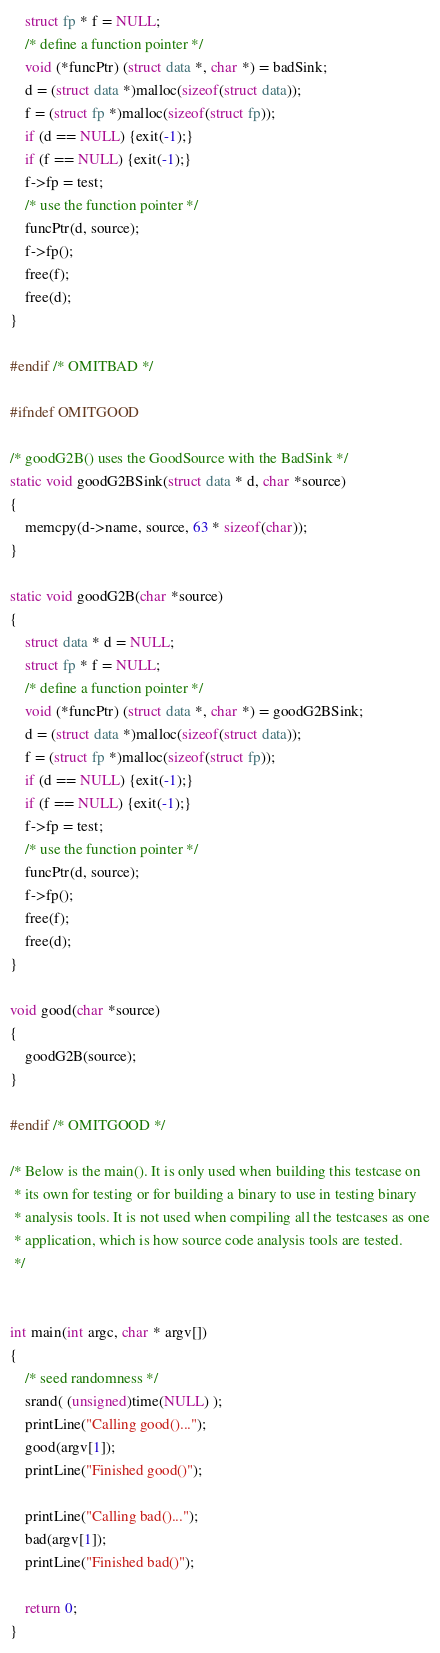<code> <loc_0><loc_0><loc_500><loc_500><_C_>    struct fp * f = NULL;
    /* define a function pointer */
    void (*funcPtr) (struct data *, char *) = badSink;
	d = (struct data *)malloc(sizeof(struct data));
	f = (struct fp *)malloc(sizeof(struct fp));
    if (d == NULL) {exit(-1);}
    if (f == NULL) {exit(-1);}
    f->fp = test;
    /* use the function pointer */
    funcPtr(d, source);
    f->fp();
    free(f);
    free(d);
}

#endif /* OMITBAD */

#ifndef OMITGOOD

/* goodG2B() uses the GoodSource with the BadSink */
static void goodG2BSink(struct data * d, char *source)
{
    memcpy(d->name, source, 63 * sizeof(char));
}

static void goodG2B(char *source)
{
    struct data * d = NULL;
    struct fp * f = NULL;
    /* define a function pointer */
    void (*funcPtr) (struct data *, char *) = goodG2BSink;
	d = (struct data *)malloc(sizeof(struct data));
	f = (struct fp *)malloc(sizeof(struct fp));
    if (d == NULL) {exit(-1);}
    if (f == NULL) {exit(-1);}
    f->fp = test;
    /* use the function pointer */
    funcPtr(d, source);
    f->fp();
    free(f);
    free(d);
}

void good(char *source)
{
    goodG2B(source);
}

#endif /* OMITGOOD */

/* Below is the main(). It is only used when building this testcase on
 * its own for testing or for building a binary to use in testing binary
 * analysis tools. It is not used when compiling all the testcases as one
 * application, which is how source code analysis tools are tested.
 */


int main(int argc, char * argv[])
{
    /* seed randomness */
    srand( (unsigned)time(NULL) );
    printLine("Calling good()...");
    good(argv[1]);
    printLine("Finished good()");
    
    printLine("Calling bad()...");
    bad(argv[1]);
    printLine("Finished bad()");
    
    return 0;
}


</code> 